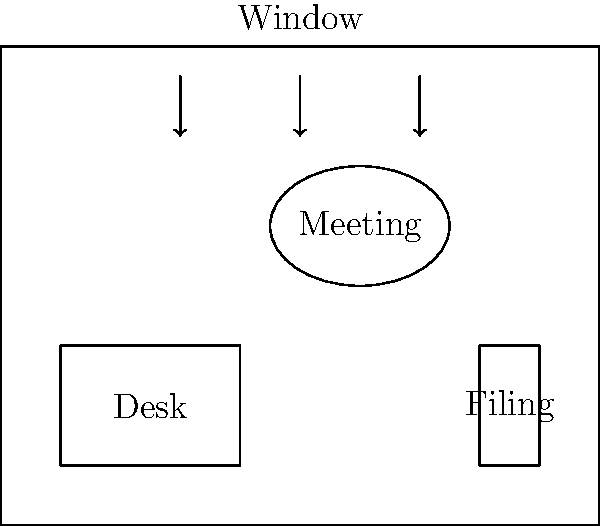Based on the floor plan diagram, which arrangement would optimize productivity for a perfectionist who values both efficiency and attention to detail? Consider factors such as natural light, proximity to resources, and potential distractions. To optimize productivity for a perfectionist, we need to consider several factors:

1. Natural light: The window provides natural light, which is beneficial for productivity and mood. The desk should be positioned to take advantage of this light without causing glare on computer screens.

2. Proximity to resources: The filing cabinet should be easily accessible from the desk to minimize time spent retrieving documents.

3. Minimizing distractions: The desk should be positioned away from high-traffic areas to reduce interruptions.

4. Meeting space: The meeting area should be separate from the main workspace to avoid disrupting focused work.

5. Organization: A perfectionist values an organized space, so there should be clear zones for different activities.

Considering these factors, the optimal arrangement would be:

1. Position the desk perpendicular to the window, facing either left or right. This allows natural light to illuminate the workspace without causing direct glare.

2. Keep the filing cabinet close to the desk for easy access to documents.

3. Place the meeting area away from the desk to minimize distractions during focused work.

4. Ensure there's enough space around the desk for organization and movement.

5. Maintain clear pathways between all areas to promote efficiency.

This arrangement balances the need for natural light, efficient resource access, and minimal distractions, which aligns with a perfectionist's desire for an optimal work environment.
Answer: Desk perpendicular to window, near filing cabinet, meeting area separate 